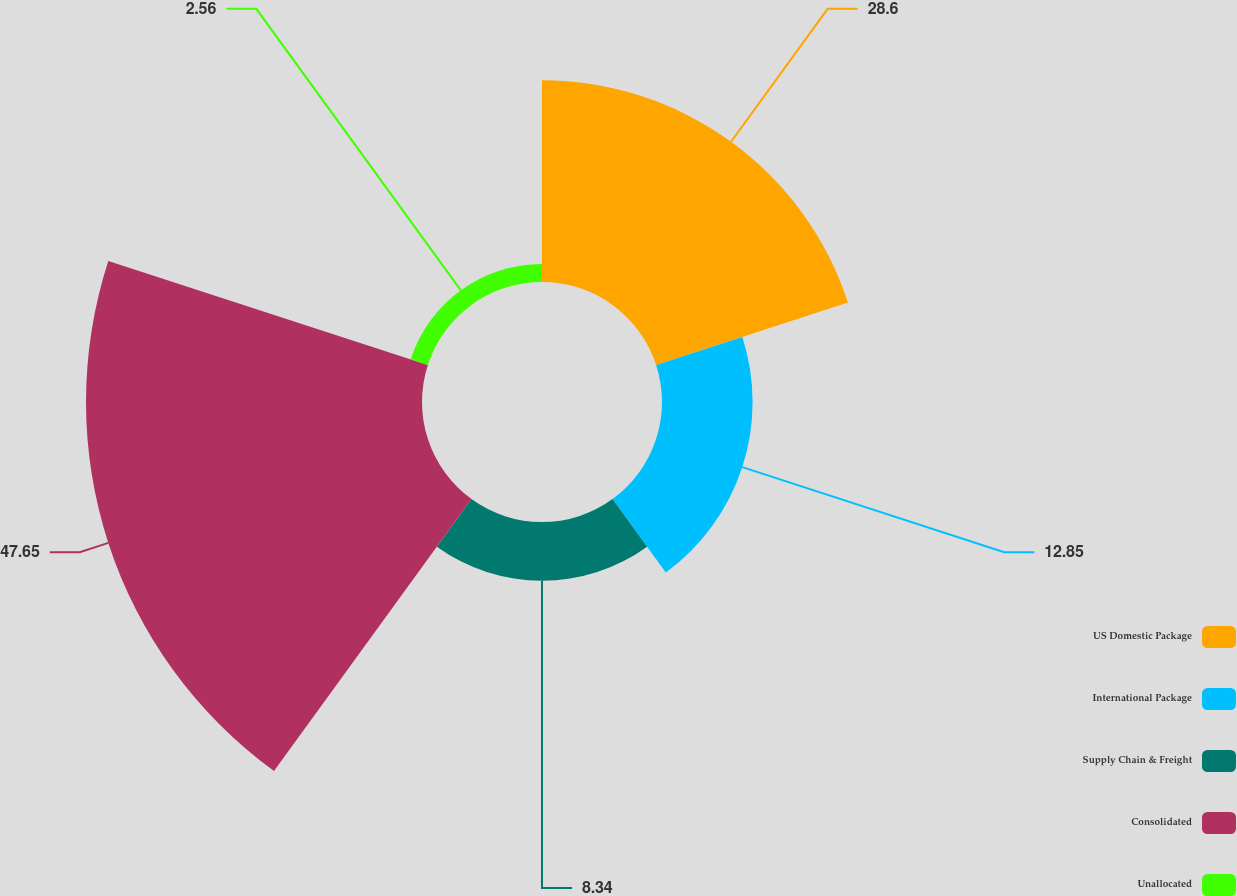Convert chart. <chart><loc_0><loc_0><loc_500><loc_500><pie_chart><fcel>US Domestic Package<fcel>International Package<fcel>Supply Chain & Freight<fcel>Consolidated<fcel>Unallocated<nl><fcel>28.6%<fcel>12.85%<fcel>8.34%<fcel>47.65%<fcel>2.56%<nl></chart> 